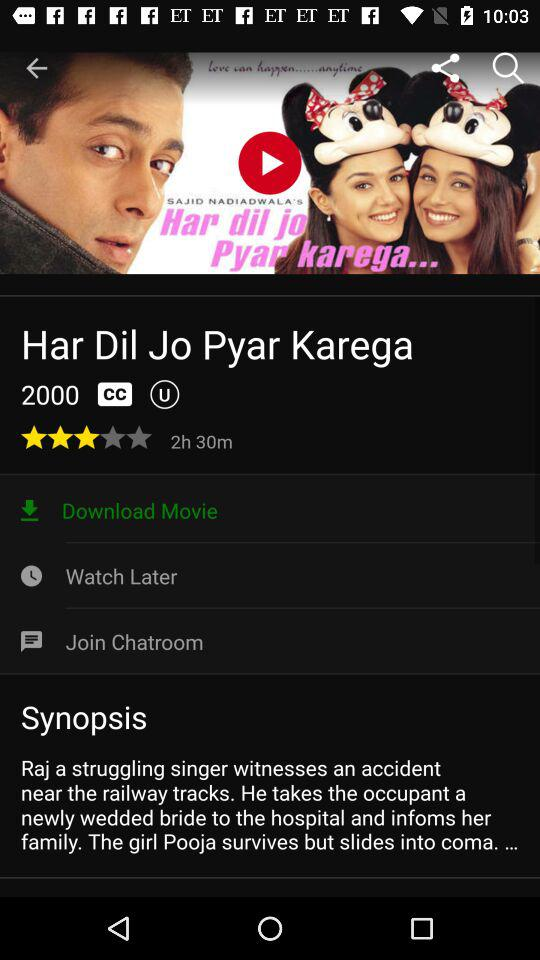What is the release year? The release year is 2000. 